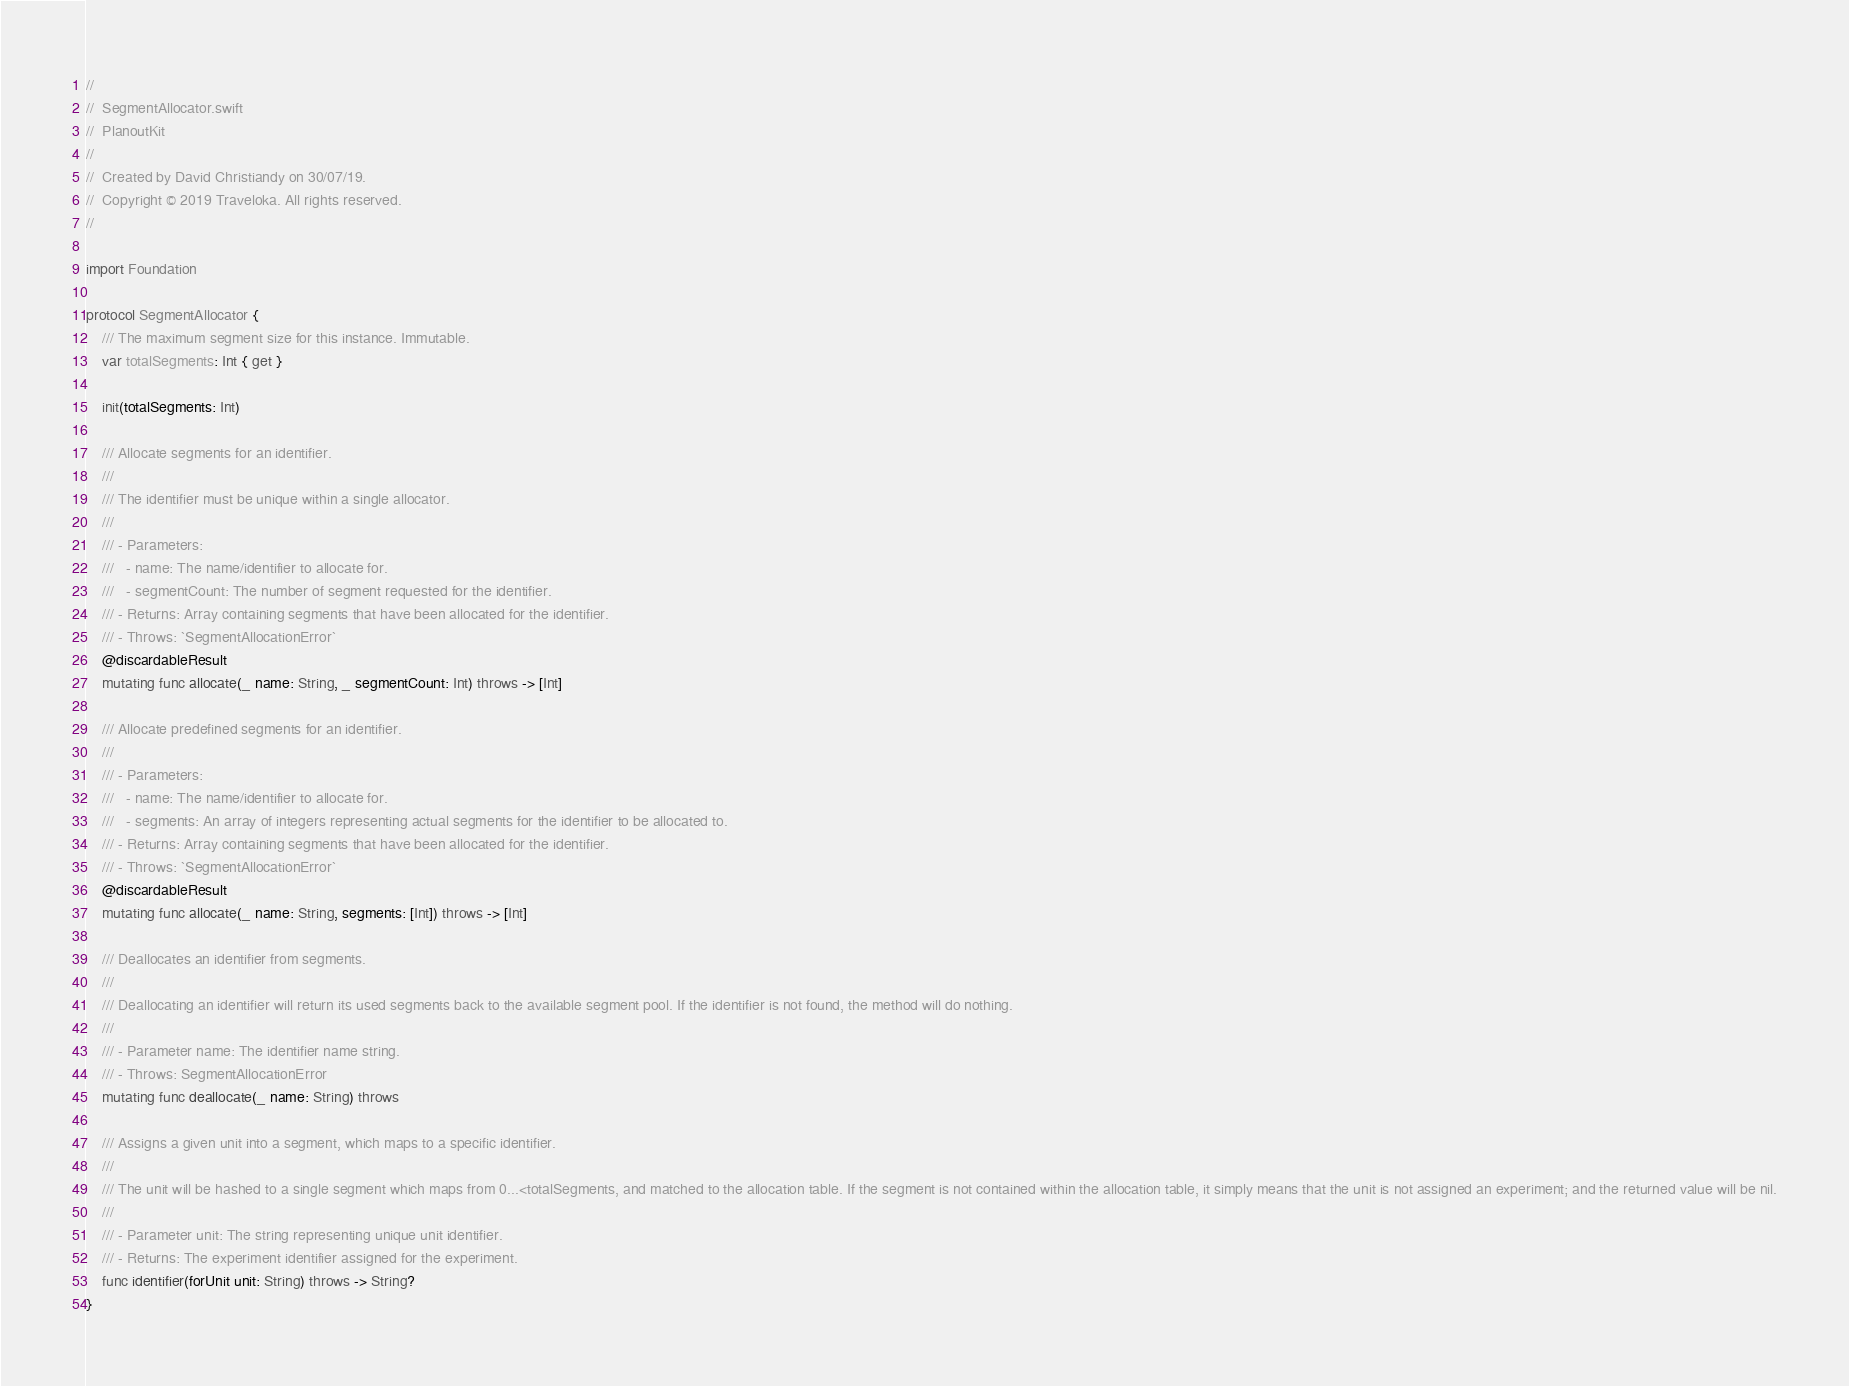Convert code to text. <code><loc_0><loc_0><loc_500><loc_500><_Swift_>//
//  SegmentAllocator.swift
//  PlanoutKit
//
//  Created by David Christiandy on 30/07/19.
//  Copyright © 2019 Traveloka. All rights reserved.
//

import Foundation

protocol SegmentAllocator {
    /// The maximum segment size for this instance. Immutable.
    var totalSegments: Int { get }

    init(totalSegments: Int)

    /// Allocate segments for an identifier.
    ///
    /// The identifier must be unique within a single allocator.
    ///
    /// - Parameters:
    ///   - name: The name/identifier to allocate for.
    ///   - segmentCount: The number of segment requested for the identifier.
    /// - Returns: Array containing segments that have been allocated for the identifier.
    /// - Throws: `SegmentAllocationError`
    @discardableResult
    mutating func allocate(_ name: String, _ segmentCount: Int) throws -> [Int]

    /// Allocate predefined segments for an identifier.
    ///
    /// - Parameters:
    ///   - name: The name/identifier to allocate for.
    ///   - segments: An array of integers representing actual segments for the identifier to be allocated to.
    /// - Returns: Array containing segments that have been allocated for the identifier.
    /// - Throws: `SegmentAllocationError`
    @discardableResult
    mutating func allocate(_ name: String, segments: [Int]) throws -> [Int]

    /// Deallocates an identifier from segments.
    ///
    /// Deallocating an identifier will return its used segments back to the available segment pool. If the identifier is not found, the method will do nothing.
    ///
    /// - Parameter name: The identifier name string.
    /// - Throws: SegmentAllocationError
    mutating func deallocate(_ name: String) throws

    /// Assigns a given unit into a segment, which maps to a specific identifier.
    ///
    /// The unit will be hashed to a single segment which maps from 0...<totalSegments, and matched to the allocation table. If the segment is not contained within the allocation table, it simply means that the unit is not assigned an experiment; and the returned value will be nil.
    ///
    /// - Parameter unit: The string representing unique unit identifier.
    /// - Returns: The experiment identifier assigned for the experiment.
    func identifier(forUnit unit: String) throws -> String?
}
</code> 